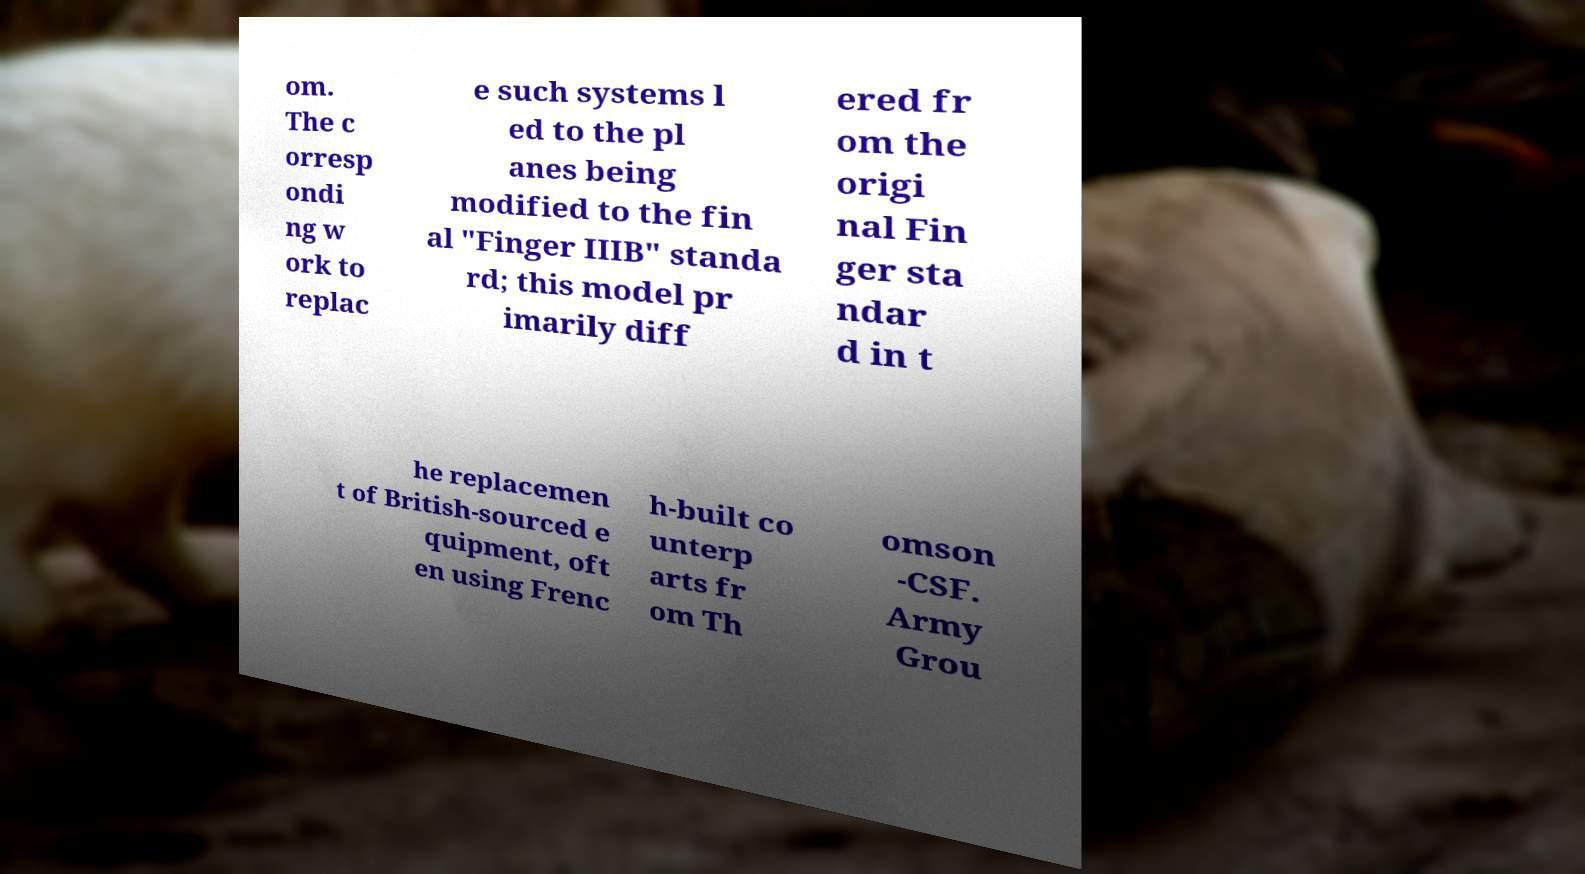Could you extract and type out the text from this image? om. The c orresp ondi ng w ork to replac e such systems l ed to the pl anes being modified to the fin al "Finger IIIB" standa rd; this model pr imarily diff ered fr om the origi nal Fin ger sta ndar d in t he replacemen t of British-sourced e quipment, oft en using Frenc h-built co unterp arts fr om Th omson -CSF. Army Grou 